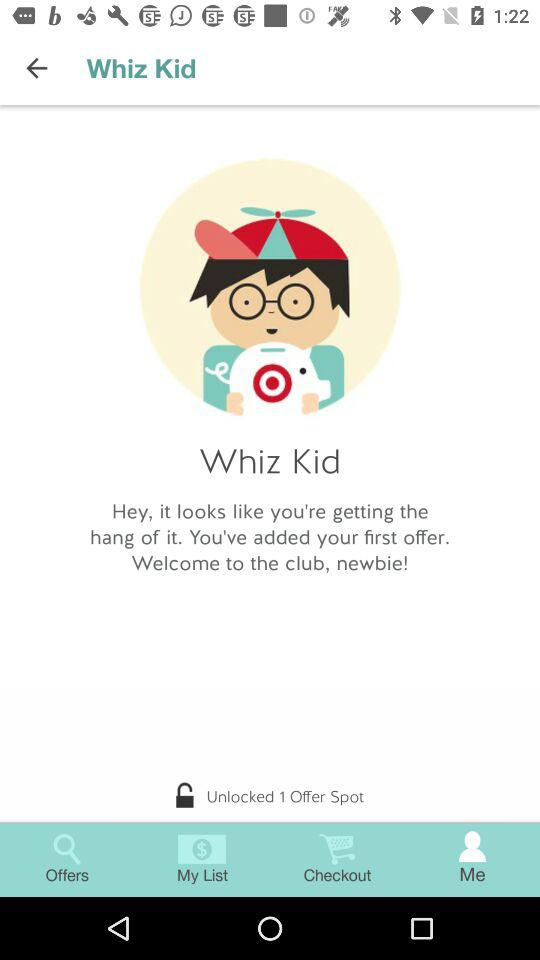How many offers has the user unlocked?
Answer the question using a single word or phrase. 1 